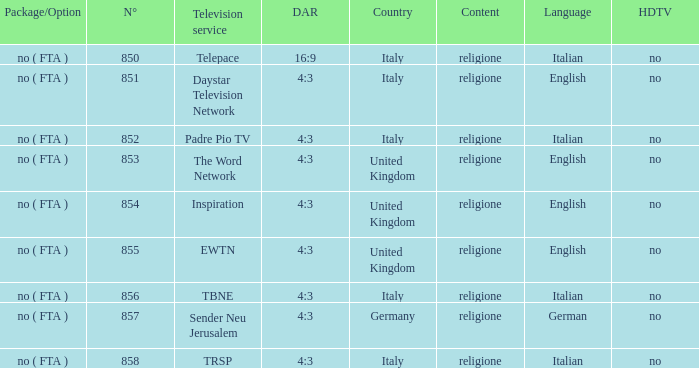How many television service are in italian and n°is greater than 856.0? TRSP. 